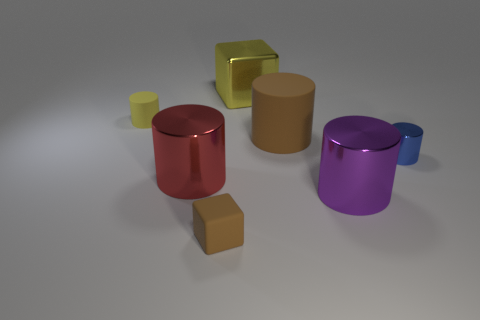Does the large purple cylinder have the same material as the small yellow cylinder?
Your response must be concise. No. There is a tiny matte object behind the blue shiny thing; is it the same color as the large cube?
Give a very brief answer. Yes. What material is the large cylinder left of the brown object in front of the big metallic cylinder to the left of the large yellow thing?
Offer a terse response. Metal. How many other objects are the same size as the red metal cylinder?
Offer a very short reply. 3. What color is the small block?
Your answer should be very brief. Brown. What number of shiny objects are either cyan blocks or big brown things?
Your response must be concise. 0. Is there any other thing that has the same material as the yellow block?
Keep it short and to the point. Yes. There is a yellow object to the left of the big metallic object that is behind the shiny cylinder that is to the left of the purple metal cylinder; what is its size?
Your answer should be compact. Small. There is a rubber thing that is both behind the large red metallic thing and to the right of the red cylinder; what is its size?
Make the answer very short. Large. Is the color of the shiny cylinder on the left side of the large brown thing the same as the small rubber object that is behind the rubber cube?
Offer a very short reply. No. 